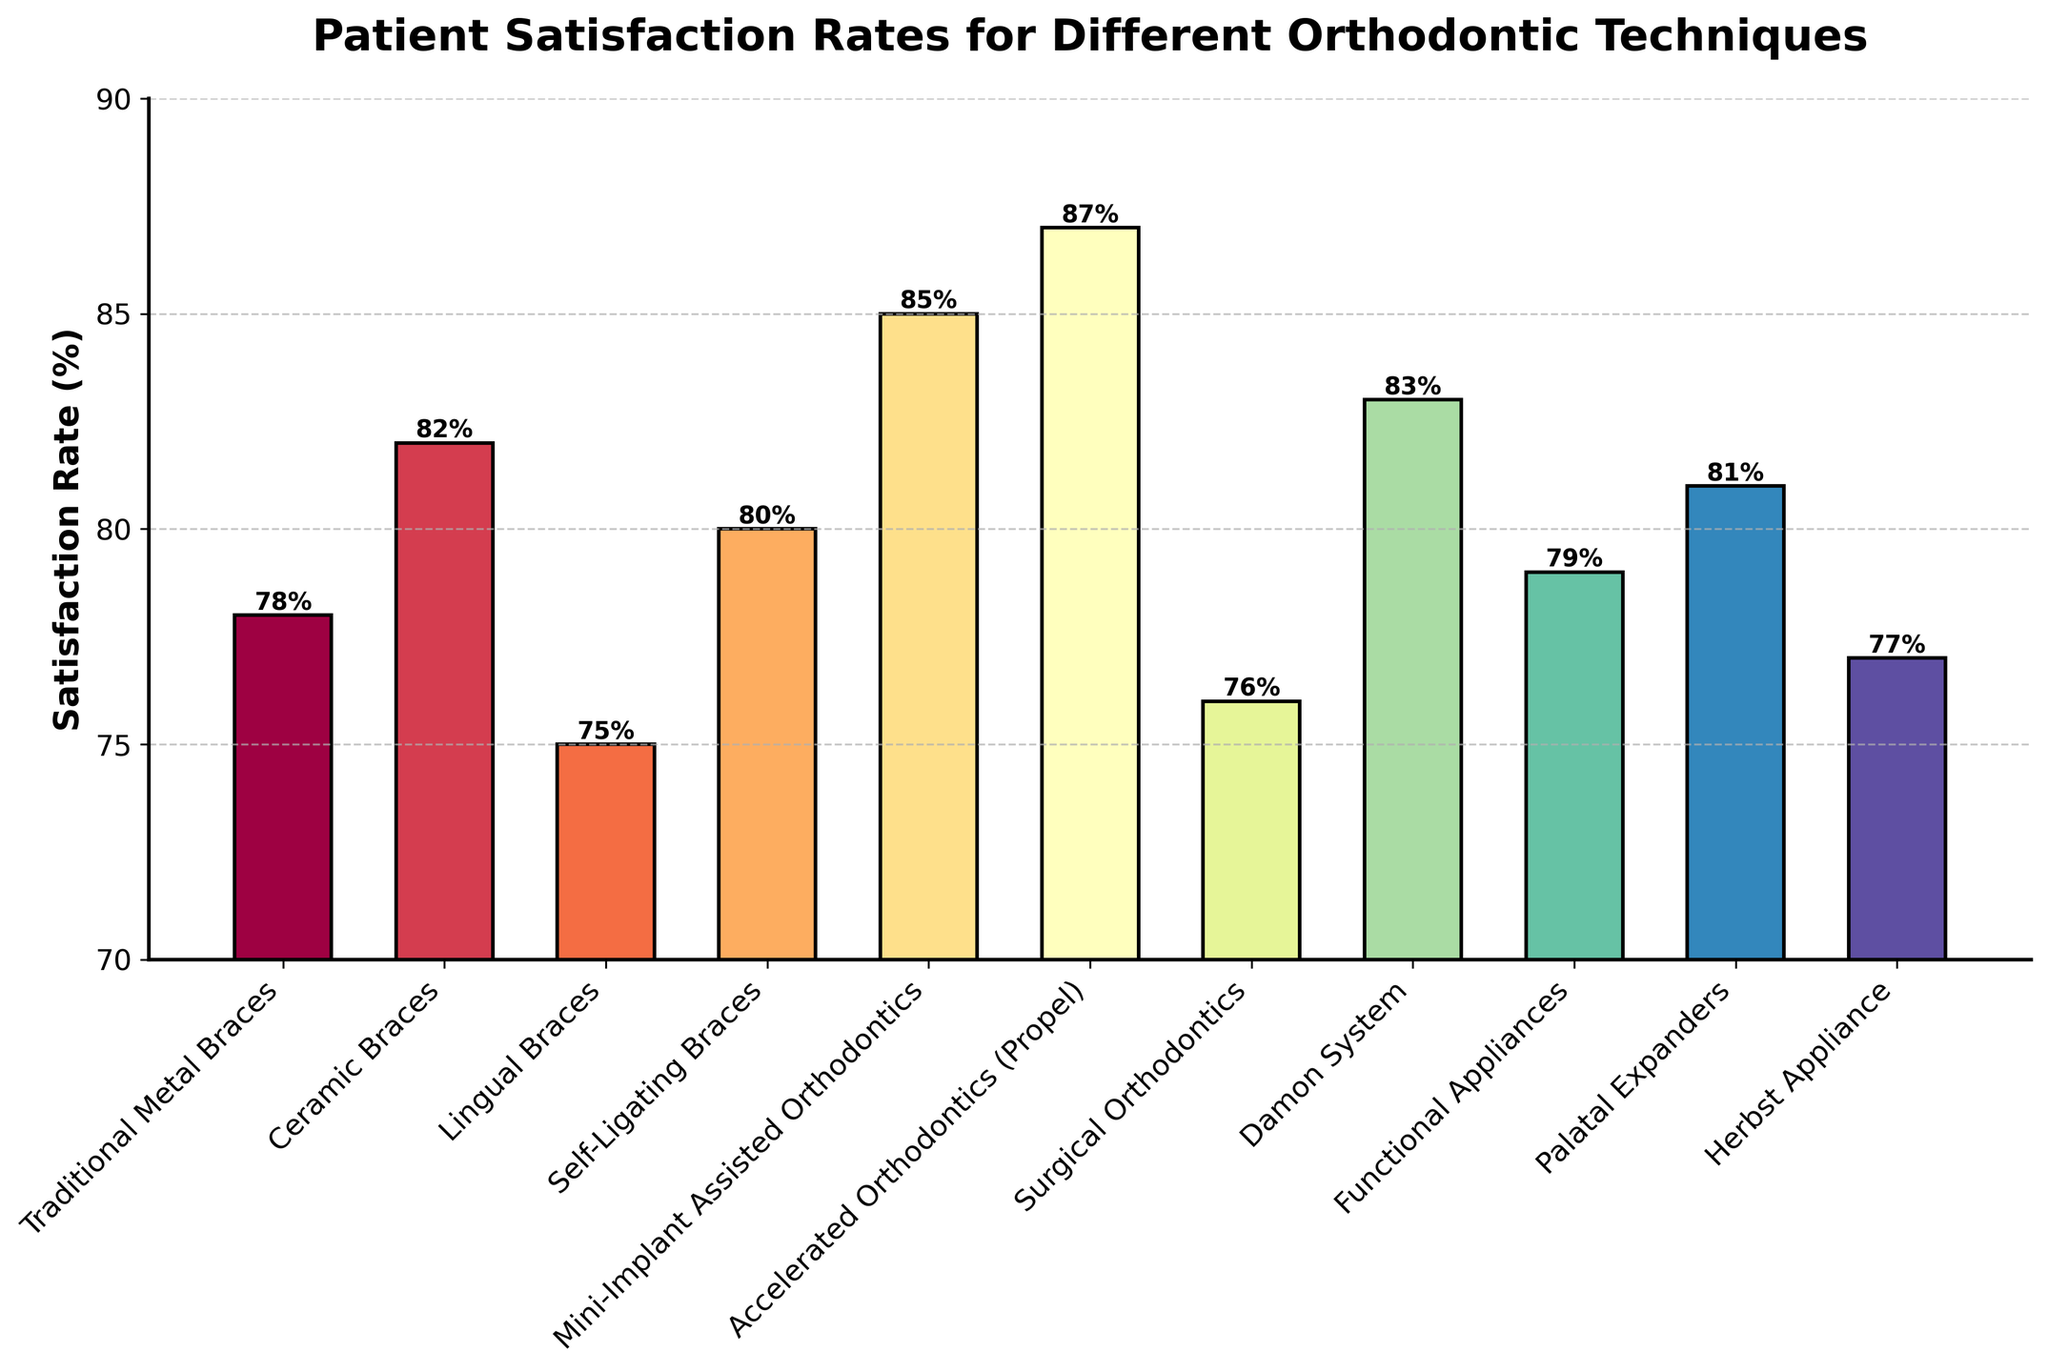Which orthodontic technique has the highest patient satisfaction rate? Look for the tallest bar in the chart. The technique associated with this bar is Accelerated Orthodontics (Propel).
Answer: Accelerated Orthodontics (Propel) What is the difference in satisfaction rate between Ceramic Braces and Traditional Metal Braces? Find the heights of the bars for Ceramic Braces and Traditional Metal Braces, which are 82% and 78% respectively. Calculate the difference: 82 - 78 = 4.
Answer: 4% Which two techniques have the closest patient satisfaction rates? Compare the heights of all bars to find the smallest difference between them. Self-Ligating Braces and Palatal Expanders have satisfaction rates of 80% and 81%, with a difference of 1%.
Answer: Self-Ligating Braces and Palatal Expanders How many techniques have a satisfaction rate of 80% or higher? Count the number of bars that reach or exceed the 80% line. There are six techniques: Ceramic Braces, Self-Ligating Braces, Mini-Implant Assisted Orthodontics, Accelerated Orthodontics (Propel), Damon System, and Palatal Expanders.
Answer: Six What is the average patient satisfaction rate for Surgical Orthodontics, Damon System, and Functional Appliances? Find the heights of the bars for Surgical Orthodontics (76%), Damon System (83%), and Functional Appliances (79%). Calculate the average: (76 + 83 + 79) / 3 ≈ 79.33.
Answer: 79.33% Which orthodontic technique has the lowest satisfaction rate? Identify the shortest bar in the chart, which corresponds to Lingual Braces with a rate of 75%.
Answer: Lingual Braces Is the satisfaction rate for Traditional Metal Braces higher or lower than for Herbst Appliance? Compare the heights of the bars for Traditional Metal Braces (78%) and Herbst Appliance (77%). 78% is higher than 77%.
Answer: Higher What is the range of satisfaction rates among all the techniques? Identify the highest and lowest bars, which correspond to Accelerated Orthodontics (Propel) at 87% and Lingual Braces at 75%. Calculate the range: 87 - 75 = 12.
Answer: 12% How much higher is the satisfaction rate for Mini-Implant Assisted Orthodontics compared to Lingual Braces? Find the satisfaction rates for Mini-Implant Assisted Orthodontics (85%) and Lingual Braces (75%). Calculate the difference: 85 - 75 = 10.
Answer: 10% Which technique's bar is positioned in the middle of the chart based on satisfaction rate? List the satisfaction rates in ascending order: 75, 76, 77, 78, 79, 80, 81, 82, 83, 85, 87. The median value is 80%, corresponding to Self-Ligating Braces.
Answer: Self-Ligating Braces 